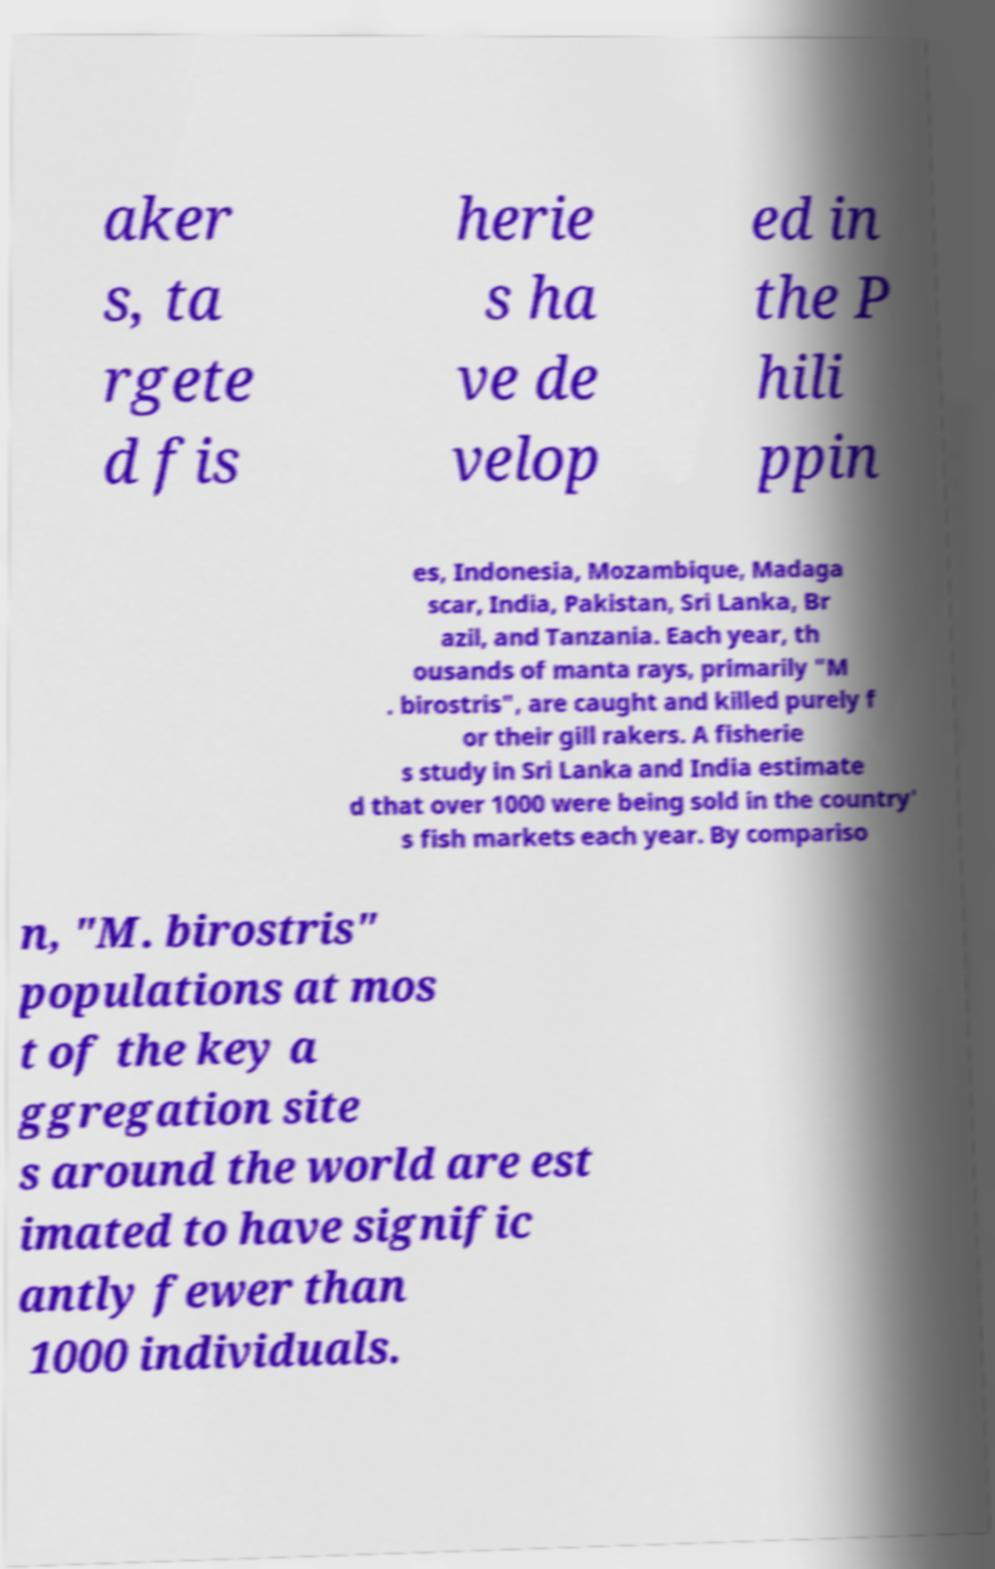Please read and relay the text visible in this image. What does it say? aker s, ta rgete d fis herie s ha ve de velop ed in the P hili ppin es, Indonesia, Mozambique, Madaga scar, India, Pakistan, Sri Lanka, Br azil, and Tanzania. Each year, th ousands of manta rays, primarily "M . birostris", are caught and killed purely f or their gill rakers. A fisherie s study in Sri Lanka and India estimate d that over 1000 were being sold in the country' s fish markets each year. By compariso n, "M. birostris" populations at mos t of the key a ggregation site s around the world are est imated to have signific antly fewer than 1000 individuals. 